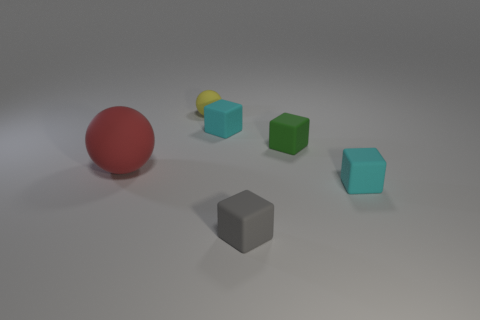How many cyan blocks must be subtracted to get 1 cyan blocks? 1 Subtract all small gray rubber cubes. How many cubes are left? 3 Add 2 small yellow shiny cylinders. How many objects exist? 8 Subtract all green cubes. How many cubes are left? 3 Subtract all purple spheres. How many cyan blocks are left? 2 Subtract 1 cubes. How many cubes are left? 3 Subtract all balls. How many objects are left? 4 Subtract all yellow blocks. Subtract all gray balls. How many blocks are left? 4 Subtract all brown matte cubes. Subtract all small cyan cubes. How many objects are left? 4 Add 1 tiny yellow rubber things. How many tiny yellow rubber things are left? 2 